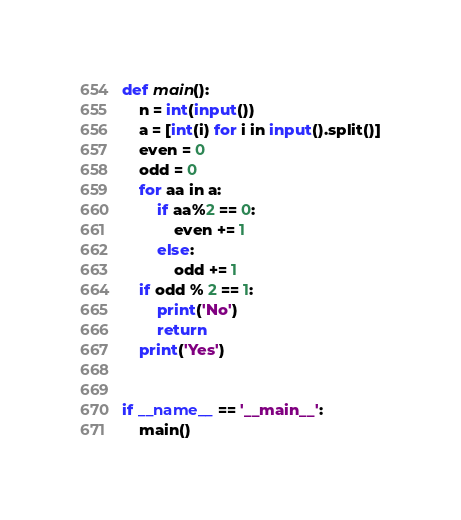Convert code to text. <code><loc_0><loc_0><loc_500><loc_500><_Python_>def main():
    n = int(input())
    a = [int(i) for i in input().split()]
    even = 0
    odd = 0
    for aa in a:
        if aa%2 == 0:
            even += 1
        else:
            odd += 1
    if odd % 2 == 1:
        print('No')
        return
    print('Yes')


if __name__ == '__main__':
    main()</code> 